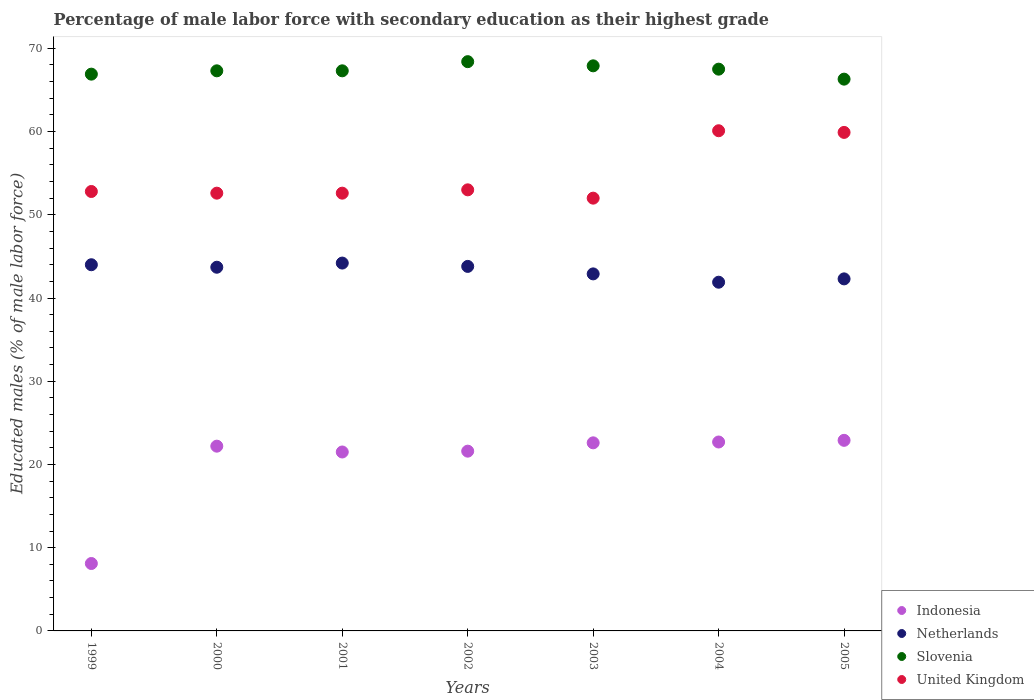How many different coloured dotlines are there?
Your answer should be very brief. 4. What is the percentage of male labor force with secondary education in Indonesia in 2004?
Ensure brevity in your answer.  22.7. Across all years, what is the maximum percentage of male labor force with secondary education in Netherlands?
Your response must be concise. 44.2. Across all years, what is the minimum percentage of male labor force with secondary education in Netherlands?
Your answer should be compact. 41.9. In which year was the percentage of male labor force with secondary education in Indonesia maximum?
Your answer should be compact. 2005. In which year was the percentage of male labor force with secondary education in United Kingdom minimum?
Provide a succinct answer. 2003. What is the total percentage of male labor force with secondary education in Indonesia in the graph?
Keep it short and to the point. 141.6. What is the difference between the percentage of male labor force with secondary education in Indonesia in 1999 and that in 2001?
Keep it short and to the point. -13.4. What is the difference between the percentage of male labor force with secondary education in Slovenia in 2003 and the percentage of male labor force with secondary education in United Kingdom in 1999?
Your response must be concise. 15.1. What is the average percentage of male labor force with secondary education in Netherlands per year?
Ensure brevity in your answer.  43.26. In the year 2000, what is the difference between the percentage of male labor force with secondary education in Indonesia and percentage of male labor force with secondary education in Slovenia?
Provide a succinct answer. -45.1. What is the ratio of the percentage of male labor force with secondary education in Slovenia in 2000 to that in 2003?
Keep it short and to the point. 0.99. What is the difference between the highest and the lowest percentage of male labor force with secondary education in United Kingdom?
Make the answer very short. 8.1. Is it the case that in every year, the sum of the percentage of male labor force with secondary education in Slovenia and percentage of male labor force with secondary education in Netherlands  is greater than the sum of percentage of male labor force with secondary education in United Kingdom and percentage of male labor force with secondary education in Indonesia?
Offer a terse response. No. Does the percentage of male labor force with secondary education in United Kingdom monotonically increase over the years?
Offer a terse response. No. Is the percentage of male labor force with secondary education in Netherlands strictly greater than the percentage of male labor force with secondary education in Slovenia over the years?
Ensure brevity in your answer.  No. How many dotlines are there?
Ensure brevity in your answer.  4. How many years are there in the graph?
Offer a terse response. 7. What is the difference between two consecutive major ticks on the Y-axis?
Your response must be concise. 10. Are the values on the major ticks of Y-axis written in scientific E-notation?
Offer a terse response. No. Does the graph contain any zero values?
Offer a terse response. No. Does the graph contain grids?
Provide a short and direct response. No. Where does the legend appear in the graph?
Your answer should be compact. Bottom right. How many legend labels are there?
Offer a terse response. 4. How are the legend labels stacked?
Offer a terse response. Vertical. What is the title of the graph?
Make the answer very short. Percentage of male labor force with secondary education as their highest grade. Does "Sierra Leone" appear as one of the legend labels in the graph?
Keep it short and to the point. No. What is the label or title of the Y-axis?
Provide a succinct answer. Educated males (% of male labor force). What is the Educated males (% of male labor force) of Indonesia in 1999?
Your response must be concise. 8.1. What is the Educated males (% of male labor force) of Slovenia in 1999?
Ensure brevity in your answer.  66.9. What is the Educated males (% of male labor force) in United Kingdom in 1999?
Make the answer very short. 52.8. What is the Educated males (% of male labor force) in Indonesia in 2000?
Ensure brevity in your answer.  22.2. What is the Educated males (% of male labor force) of Netherlands in 2000?
Your response must be concise. 43.7. What is the Educated males (% of male labor force) of Slovenia in 2000?
Provide a short and direct response. 67.3. What is the Educated males (% of male labor force) of United Kingdom in 2000?
Give a very brief answer. 52.6. What is the Educated males (% of male labor force) in Indonesia in 2001?
Your answer should be compact. 21.5. What is the Educated males (% of male labor force) in Netherlands in 2001?
Your answer should be very brief. 44.2. What is the Educated males (% of male labor force) of Slovenia in 2001?
Provide a succinct answer. 67.3. What is the Educated males (% of male labor force) of United Kingdom in 2001?
Offer a very short reply. 52.6. What is the Educated males (% of male labor force) of Indonesia in 2002?
Provide a succinct answer. 21.6. What is the Educated males (% of male labor force) of Netherlands in 2002?
Keep it short and to the point. 43.8. What is the Educated males (% of male labor force) of Slovenia in 2002?
Your answer should be very brief. 68.4. What is the Educated males (% of male labor force) of Indonesia in 2003?
Provide a short and direct response. 22.6. What is the Educated males (% of male labor force) of Netherlands in 2003?
Offer a terse response. 42.9. What is the Educated males (% of male labor force) of Slovenia in 2003?
Ensure brevity in your answer.  67.9. What is the Educated males (% of male labor force) in United Kingdom in 2003?
Ensure brevity in your answer.  52. What is the Educated males (% of male labor force) of Indonesia in 2004?
Keep it short and to the point. 22.7. What is the Educated males (% of male labor force) in Netherlands in 2004?
Provide a succinct answer. 41.9. What is the Educated males (% of male labor force) in Slovenia in 2004?
Make the answer very short. 67.5. What is the Educated males (% of male labor force) of United Kingdom in 2004?
Provide a short and direct response. 60.1. What is the Educated males (% of male labor force) of Indonesia in 2005?
Keep it short and to the point. 22.9. What is the Educated males (% of male labor force) in Netherlands in 2005?
Offer a terse response. 42.3. What is the Educated males (% of male labor force) of Slovenia in 2005?
Make the answer very short. 66.3. What is the Educated males (% of male labor force) in United Kingdom in 2005?
Provide a short and direct response. 59.9. Across all years, what is the maximum Educated males (% of male labor force) of Indonesia?
Provide a succinct answer. 22.9. Across all years, what is the maximum Educated males (% of male labor force) of Netherlands?
Your response must be concise. 44.2. Across all years, what is the maximum Educated males (% of male labor force) of Slovenia?
Make the answer very short. 68.4. Across all years, what is the maximum Educated males (% of male labor force) in United Kingdom?
Give a very brief answer. 60.1. Across all years, what is the minimum Educated males (% of male labor force) in Indonesia?
Provide a short and direct response. 8.1. Across all years, what is the minimum Educated males (% of male labor force) in Netherlands?
Provide a short and direct response. 41.9. Across all years, what is the minimum Educated males (% of male labor force) of Slovenia?
Offer a terse response. 66.3. What is the total Educated males (% of male labor force) in Indonesia in the graph?
Make the answer very short. 141.6. What is the total Educated males (% of male labor force) of Netherlands in the graph?
Keep it short and to the point. 302.8. What is the total Educated males (% of male labor force) of Slovenia in the graph?
Offer a terse response. 471.6. What is the total Educated males (% of male labor force) in United Kingdom in the graph?
Offer a terse response. 383. What is the difference between the Educated males (% of male labor force) in Indonesia in 1999 and that in 2000?
Keep it short and to the point. -14.1. What is the difference between the Educated males (% of male labor force) of Netherlands in 1999 and that in 2000?
Make the answer very short. 0.3. What is the difference between the Educated males (% of male labor force) in Slovenia in 1999 and that in 2000?
Provide a succinct answer. -0.4. What is the difference between the Educated males (% of male labor force) of United Kingdom in 1999 and that in 2001?
Your answer should be very brief. 0.2. What is the difference between the Educated males (% of male labor force) in Slovenia in 1999 and that in 2002?
Offer a terse response. -1.5. What is the difference between the Educated males (% of male labor force) of Slovenia in 1999 and that in 2003?
Provide a succinct answer. -1. What is the difference between the Educated males (% of male labor force) of United Kingdom in 1999 and that in 2003?
Your response must be concise. 0.8. What is the difference between the Educated males (% of male labor force) in Indonesia in 1999 and that in 2004?
Offer a very short reply. -14.6. What is the difference between the Educated males (% of male labor force) of United Kingdom in 1999 and that in 2004?
Keep it short and to the point. -7.3. What is the difference between the Educated males (% of male labor force) of Indonesia in 1999 and that in 2005?
Provide a succinct answer. -14.8. What is the difference between the Educated males (% of male labor force) in Slovenia in 2000 and that in 2001?
Your response must be concise. 0. What is the difference between the Educated males (% of male labor force) of Netherlands in 2000 and that in 2002?
Make the answer very short. -0.1. What is the difference between the Educated males (% of male labor force) in Slovenia in 2000 and that in 2003?
Your answer should be very brief. -0.6. What is the difference between the Educated males (% of male labor force) in United Kingdom in 2000 and that in 2003?
Make the answer very short. 0.6. What is the difference between the Educated males (% of male labor force) of Indonesia in 2000 and that in 2004?
Your response must be concise. -0.5. What is the difference between the Educated males (% of male labor force) in Slovenia in 2000 and that in 2004?
Offer a very short reply. -0.2. What is the difference between the Educated males (% of male labor force) of United Kingdom in 2000 and that in 2004?
Make the answer very short. -7.5. What is the difference between the Educated males (% of male labor force) of Indonesia in 2000 and that in 2005?
Your answer should be compact. -0.7. What is the difference between the Educated males (% of male labor force) of Indonesia in 2001 and that in 2002?
Offer a terse response. -0.1. What is the difference between the Educated males (% of male labor force) of Netherlands in 2001 and that in 2002?
Provide a succinct answer. 0.4. What is the difference between the Educated males (% of male labor force) of Slovenia in 2001 and that in 2002?
Your response must be concise. -1.1. What is the difference between the Educated males (% of male labor force) of Indonesia in 2001 and that in 2003?
Make the answer very short. -1.1. What is the difference between the Educated males (% of male labor force) in Netherlands in 2001 and that in 2003?
Keep it short and to the point. 1.3. What is the difference between the Educated males (% of male labor force) of Indonesia in 2001 and that in 2004?
Make the answer very short. -1.2. What is the difference between the Educated males (% of male labor force) of Netherlands in 2001 and that in 2004?
Keep it short and to the point. 2.3. What is the difference between the Educated males (% of male labor force) in Indonesia in 2001 and that in 2005?
Ensure brevity in your answer.  -1.4. What is the difference between the Educated males (% of male labor force) in Netherlands in 2001 and that in 2005?
Provide a succinct answer. 1.9. What is the difference between the Educated males (% of male labor force) in Slovenia in 2001 and that in 2005?
Keep it short and to the point. 1. What is the difference between the Educated males (% of male labor force) in United Kingdom in 2002 and that in 2003?
Your answer should be compact. 1. What is the difference between the Educated males (% of male labor force) of Netherlands in 2002 and that in 2004?
Offer a very short reply. 1.9. What is the difference between the Educated males (% of male labor force) of Slovenia in 2002 and that in 2004?
Offer a very short reply. 0.9. What is the difference between the Educated males (% of male labor force) of Indonesia in 2002 and that in 2005?
Provide a short and direct response. -1.3. What is the difference between the Educated males (% of male labor force) in United Kingdom in 2002 and that in 2005?
Your response must be concise. -6.9. What is the difference between the Educated males (% of male labor force) in Indonesia in 2003 and that in 2004?
Offer a very short reply. -0.1. What is the difference between the Educated males (% of male labor force) of Slovenia in 2003 and that in 2004?
Offer a very short reply. 0.4. What is the difference between the Educated males (% of male labor force) in Indonesia in 2003 and that in 2005?
Keep it short and to the point. -0.3. What is the difference between the Educated males (% of male labor force) in Slovenia in 2003 and that in 2005?
Ensure brevity in your answer.  1.6. What is the difference between the Educated males (% of male labor force) in United Kingdom in 2003 and that in 2005?
Ensure brevity in your answer.  -7.9. What is the difference between the Educated males (% of male labor force) in Indonesia in 2004 and that in 2005?
Provide a succinct answer. -0.2. What is the difference between the Educated males (% of male labor force) in Netherlands in 2004 and that in 2005?
Offer a very short reply. -0.4. What is the difference between the Educated males (% of male labor force) of Slovenia in 2004 and that in 2005?
Your answer should be very brief. 1.2. What is the difference between the Educated males (% of male labor force) of Indonesia in 1999 and the Educated males (% of male labor force) of Netherlands in 2000?
Offer a terse response. -35.6. What is the difference between the Educated males (% of male labor force) in Indonesia in 1999 and the Educated males (% of male labor force) in Slovenia in 2000?
Provide a succinct answer. -59.2. What is the difference between the Educated males (% of male labor force) of Indonesia in 1999 and the Educated males (% of male labor force) of United Kingdom in 2000?
Provide a short and direct response. -44.5. What is the difference between the Educated males (% of male labor force) in Netherlands in 1999 and the Educated males (% of male labor force) in Slovenia in 2000?
Keep it short and to the point. -23.3. What is the difference between the Educated males (% of male labor force) in Netherlands in 1999 and the Educated males (% of male labor force) in United Kingdom in 2000?
Your response must be concise. -8.6. What is the difference between the Educated males (% of male labor force) of Indonesia in 1999 and the Educated males (% of male labor force) of Netherlands in 2001?
Make the answer very short. -36.1. What is the difference between the Educated males (% of male labor force) in Indonesia in 1999 and the Educated males (% of male labor force) in Slovenia in 2001?
Provide a succinct answer. -59.2. What is the difference between the Educated males (% of male labor force) of Indonesia in 1999 and the Educated males (% of male labor force) of United Kingdom in 2001?
Provide a succinct answer. -44.5. What is the difference between the Educated males (% of male labor force) in Netherlands in 1999 and the Educated males (% of male labor force) in Slovenia in 2001?
Your answer should be compact. -23.3. What is the difference between the Educated males (% of male labor force) of Slovenia in 1999 and the Educated males (% of male labor force) of United Kingdom in 2001?
Your answer should be very brief. 14.3. What is the difference between the Educated males (% of male labor force) of Indonesia in 1999 and the Educated males (% of male labor force) of Netherlands in 2002?
Your answer should be compact. -35.7. What is the difference between the Educated males (% of male labor force) in Indonesia in 1999 and the Educated males (% of male labor force) in Slovenia in 2002?
Your answer should be very brief. -60.3. What is the difference between the Educated males (% of male labor force) of Indonesia in 1999 and the Educated males (% of male labor force) of United Kingdom in 2002?
Offer a terse response. -44.9. What is the difference between the Educated males (% of male labor force) in Netherlands in 1999 and the Educated males (% of male labor force) in Slovenia in 2002?
Provide a short and direct response. -24.4. What is the difference between the Educated males (% of male labor force) in Slovenia in 1999 and the Educated males (% of male labor force) in United Kingdom in 2002?
Provide a succinct answer. 13.9. What is the difference between the Educated males (% of male labor force) in Indonesia in 1999 and the Educated males (% of male labor force) in Netherlands in 2003?
Keep it short and to the point. -34.8. What is the difference between the Educated males (% of male labor force) of Indonesia in 1999 and the Educated males (% of male labor force) of Slovenia in 2003?
Your answer should be compact. -59.8. What is the difference between the Educated males (% of male labor force) of Indonesia in 1999 and the Educated males (% of male labor force) of United Kingdom in 2003?
Your response must be concise. -43.9. What is the difference between the Educated males (% of male labor force) in Netherlands in 1999 and the Educated males (% of male labor force) in Slovenia in 2003?
Keep it short and to the point. -23.9. What is the difference between the Educated males (% of male labor force) of Slovenia in 1999 and the Educated males (% of male labor force) of United Kingdom in 2003?
Provide a succinct answer. 14.9. What is the difference between the Educated males (% of male labor force) of Indonesia in 1999 and the Educated males (% of male labor force) of Netherlands in 2004?
Keep it short and to the point. -33.8. What is the difference between the Educated males (% of male labor force) of Indonesia in 1999 and the Educated males (% of male labor force) of Slovenia in 2004?
Offer a terse response. -59.4. What is the difference between the Educated males (% of male labor force) in Indonesia in 1999 and the Educated males (% of male labor force) in United Kingdom in 2004?
Give a very brief answer. -52. What is the difference between the Educated males (% of male labor force) of Netherlands in 1999 and the Educated males (% of male labor force) of Slovenia in 2004?
Offer a terse response. -23.5. What is the difference between the Educated males (% of male labor force) of Netherlands in 1999 and the Educated males (% of male labor force) of United Kingdom in 2004?
Give a very brief answer. -16.1. What is the difference between the Educated males (% of male labor force) of Indonesia in 1999 and the Educated males (% of male labor force) of Netherlands in 2005?
Make the answer very short. -34.2. What is the difference between the Educated males (% of male labor force) in Indonesia in 1999 and the Educated males (% of male labor force) in Slovenia in 2005?
Give a very brief answer. -58.2. What is the difference between the Educated males (% of male labor force) in Indonesia in 1999 and the Educated males (% of male labor force) in United Kingdom in 2005?
Offer a terse response. -51.8. What is the difference between the Educated males (% of male labor force) of Netherlands in 1999 and the Educated males (% of male labor force) of Slovenia in 2005?
Make the answer very short. -22.3. What is the difference between the Educated males (% of male labor force) of Netherlands in 1999 and the Educated males (% of male labor force) of United Kingdom in 2005?
Offer a very short reply. -15.9. What is the difference between the Educated males (% of male labor force) of Indonesia in 2000 and the Educated males (% of male labor force) of Netherlands in 2001?
Ensure brevity in your answer.  -22. What is the difference between the Educated males (% of male labor force) in Indonesia in 2000 and the Educated males (% of male labor force) in Slovenia in 2001?
Offer a terse response. -45.1. What is the difference between the Educated males (% of male labor force) of Indonesia in 2000 and the Educated males (% of male labor force) of United Kingdom in 2001?
Ensure brevity in your answer.  -30.4. What is the difference between the Educated males (% of male labor force) in Netherlands in 2000 and the Educated males (% of male labor force) in Slovenia in 2001?
Offer a very short reply. -23.6. What is the difference between the Educated males (% of male labor force) of Slovenia in 2000 and the Educated males (% of male labor force) of United Kingdom in 2001?
Make the answer very short. 14.7. What is the difference between the Educated males (% of male labor force) in Indonesia in 2000 and the Educated males (% of male labor force) in Netherlands in 2002?
Your response must be concise. -21.6. What is the difference between the Educated males (% of male labor force) in Indonesia in 2000 and the Educated males (% of male labor force) in Slovenia in 2002?
Ensure brevity in your answer.  -46.2. What is the difference between the Educated males (% of male labor force) in Indonesia in 2000 and the Educated males (% of male labor force) in United Kingdom in 2002?
Offer a very short reply. -30.8. What is the difference between the Educated males (% of male labor force) in Netherlands in 2000 and the Educated males (% of male labor force) in Slovenia in 2002?
Your answer should be compact. -24.7. What is the difference between the Educated males (% of male labor force) in Netherlands in 2000 and the Educated males (% of male labor force) in United Kingdom in 2002?
Your answer should be compact. -9.3. What is the difference between the Educated males (% of male labor force) of Slovenia in 2000 and the Educated males (% of male labor force) of United Kingdom in 2002?
Offer a terse response. 14.3. What is the difference between the Educated males (% of male labor force) of Indonesia in 2000 and the Educated males (% of male labor force) of Netherlands in 2003?
Ensure brevity in your answer.  -20.7. What is the difference between the Educated males (% of male labor force) of Indonesia in 2000 and the Educated males (% of male labor force) of Slovenia in 2003?
Ensure brevity in your answer.  -45.7. What is the difference between the Educated males (% of male labor force) in Indonesia in 2000 and the Educated males (% of male labor force) in United Kingdom in 2003?
Provide a succinct answer. -29.8. What is the difference between the Educated males (% of male labor force) of Netherlands in 2000 and the Educated males (% of male labor force) of Slovenia in 2003?
Keep it short and to the point. -24.2. What is the difference between the Educated males (% of male labor force) in Slovenia in 2000 and the Educated males (% of male labor force) in United Kingdom in 2003?
Your response must be concise. 15.3. What is the difference between the Educated males (% of male labor force) in Indonesia in 2000 and the Educated males (% of male labor force) in Netherlands in 2004?
Keep it short and to the point. -19.7. What is the difference between the Educated males (% of male labor force) of Indonesia in 2000 and the Educated males (% of male labor force) of Slovenia in 2004?
Give a very brief answer. -45.3. What is the difference between the Educated males (% of male labor force) in Indonesia in 2000 and the Educated males (% of male labor force) in United Kingdom in 2004?
Keep it short and to the point. -37.9. What is the difference between the Educated males (% of male labor force) in Netherlands in 2000 and the Educated males (% of male labor force) in Slovenia in 2004?
Offer a terse response. -23.8. What is the difference between the Educated males (% of male labor force) in Netherlands in 2000 and the Educated males (% of male labor force) in United Kingdom in 2004?
Make the answer very short. -16.4. What is the difference between the Educated males (% of male labor force) of Slovenia in 2000 and the Educated males (% of male labor force) of United Kingdom in 2004?
Provide a short and direct response. 7.2. What is the difference between the Educated males (% of male labor force) in Indonesia in 2000 and the Educated males (% of male labor force) in Netherlands in 2005?
Your answer should be very brief. -20.1. What is the difference between the Educated males (% of male labor force) of Indonesia in 2000 and the Educated males (% of male labor force) of Slovenia in 2005?
Provide a succinct answer. -44.1. What is the difference between the Educated males (% of male labor force) in Indonesia in 2000 and the Educated males (% of male labor force) in United Kingdom in 2005?
Give a very brief answer. -37.7. What is the difference between the Educated males (% of male labor force) of Netherlands in 2000 and the Educated males (% of male labor force) of Slovenia in 2005?
Your answer should be compact. -22.6. What is the difference between the Educated males (% of male labor force) in Netherlands in 2000 and the Educated males (% of male labor force) in United Kingdom in 2005?
Keep it short and to the point. -16.2. What is the difference between the Educated males (% of male labor force) of Slovenia in 2000 and the Educated males (% of male labor force) of United Kingdom in 2005?
Your answer should be compact. 7.4. What is the difference between the Educated males (% of male labor force) in Indonesia in 2001 and the Educated males (% of male labor force) in Netherlands in 2002?
Provide a short and direct response. -22.3. What is the difference between the Educated males (% of male labor force) in Indonesia in 2001 and the Educated males (% of male labor force) in Slovenia in 2002?
Your answer should be very brief. -46.9. What is the difference between the Educated males (% of male labor force) of Indonesia in 2001 and the Educated males (% of male labor force) of United Kingdom in 2002?
Keep it short and to the point. -31.5. What is the difference between the Educated males (% of male labor force) of Netherlands in 2001 and the Educated males (% of male labor force) of Slovenia in 2002?
Your response must be concise. -24.2. What is the difference between the Educated males (% of male labor force) in Indonesia in 2001 and the Educated males (% of male labor force) in Netherlands in 2003?
Your answer should be compact. -21.4. What is the difference between the Educated males (% of male labor force) in Indonesia in 2001 and the Educated males (% of male labor force) in Slovenia in 2003?
Your answer should be compact. -46.4. What is the difference between the Educated males (% of male labor force) of Indonesia in 2001 and the Educated males (% of male labor force) of United Kingdom in 2003?
Offer a terse response. -30.5. What is the difference between the Educated males (% of male labor force) of Netherlands in 2001 and the Educated males (% of male labor force) of Slovenia in 2003?
Offer a very short reply. -23.7. What is the difference between the Educated males (% of male labor force) in Slovenia in 2001 and the Educated males (% of male labor force) in United Kingdom in 2003?
Your response must be concise. 15.3. What is the difference between the Educated males (% of male labor force) of Indonesia in 2001 and the Educated males (% of male labor force) of Netherlands in 2004?
Ensure brevity in your answer.  -20.4. What is the difference between the Educated males (% of male labor force) of Indonesia in 2001 and the Educated males (% of male labor force) of Slovenia in 2004?
Make the answer very short. -46. What is the difference between the Educated males (% of male labor force) in Indonesia in 2001 and the Educated males (% of male labor force) in United Kingdom in 2004?
Your answer should be very brief. -38.6. What is the difference between the Educated males (% of male labor force) of Netherlands in 2001 and the Educated males (% of male labor force) of Slovenia in 2004?
Your answer should be very brief. -23.3. What is the difference between the Educated males (% of male labor force) in Netherlands in 2001 and the Educated males (% of male labor force) in United Kingdom in 2004?
Ensure brevity in your answer.  -15.9. What is the difference between the Educated males (% of male labor force) in Indonesia in 2001 and the Educated males (% of male labor force) in Netherlands in 2005?
Your answer should be very brief. -20.8. What is the difference between the Educated males (% of male labor force) of Indonesia in 2001 and the Educated males (% of male labor force) of Slovenia in 2005?
Provide a succinct answer. -44.8. What is the difference between the Educated males (% of male labor force) in Indonesia in 2001 and the Educated males (% of male labor force) in United Kingdom in 2005?
Provide a short and direct response. -38.4. What is the difference between the Educated males (% of male labor force) of Netherlands in 2001 and the Educated males (% of male labor force) of Slovenia in 2005?
Keep it short and to the point. -22.1. What is the difference between the Educated males (% of male labor force) in Netherlands in 2001 and the Educated males (% of male labor force) in United Kingdom in 2005?
Your answer should be compact. -15.7. What is the difference between the Educated males (% of male labor force) in Slovenia in 2001 and the Educated males (% of male labor force) in United Kingdom in 2005?
Make the answer very short. 7.4. What is the difference between the Educated males (% of male labor force) of Indonesia in 2002 and the Educated males (% of male labor force) of Netherlands in 2003?
Your answer should be compact. -21.3. What is the difference between the Educated males (% of male labor force) in Indonesia in 2002 and the Educated males (% of male labor force) in Slovenia in 2003?
Provide a succinct answer. -46.3. What is the difference between the Educated males (% of male labor force) in Indonesia in 2002 and the Educated males (% of male labor force) in United Kingdom in 2003?
Your answer should be compact. -30.4. What is the difference between the Educated males (% of male labor force) in Netherlands in 2002 and the Educated males (% of male labor force) in Slovenia in 2003?
Ensure brevity in your answer.  -24.1. What is the difference between the Educated males (% of male labor force) in Netherlands in 2002 and the Educated males (% of male labor force) in United Kingdom in 2003?
Give a very brief answer. -8.2. What is the difference between the Educated males (% of male labor force) in Indonesia in 2002 and the Educated males (% of male labor force) in Netherlands in 2004?
Ensure brevity in your answer.  -20.3. What is the difference between the Educated males (% of male labor force) in Indonesia in 2002 and the Educated males (% of male labor force) in Slovenia in 2004?
Your answer should be compact. -45.9. What is the difference between the Educated males (% of male labor force) in Indonesia in 2002 and the Educated males (% of male labor force) in United Kingdom in 2004?
Keep it short and to the point. -38.5. What is the difference between the Educated males (% of male labor force) in Netherlands in 2002 and the Educated males (% of male labor force) in Slovenia in 2004?
Provide a short and direct response. -23.7. What is the difference between the Educated males (% of male labor force) in Netherlands in 2002 and the Educated males (% of male labor force) in United Kingdom in 2004?
Give a very brief answer. -16.3. What is the difference between the Educated males (% of male labor force) in Indonesia in 2002 and the Educated males (% of male labor force) in Netherlands in 2005?
Keep it short and to the point. -20.7. What is the difference between the Educated males (% of male labor force) in Indonesia in 2002 and the Educated males (% of male labor force) in Slovenia in 2005?
Provide a short and direct response. -44.7. What is the difference between the Educated males (% of male labor force) in Indonesia in 2002 and the Educated males (% of male labor force) in United Kingdom in 2005?
Keep it short and to the point. -38.3. What is the difference between the Educated males (% of male labor force) of Netherlands in 2002 and the Educated males (% of male labor force) of Slovenia in 2005?
Keep it short and to the point. -22.5. What is the difference between the Educated males (% of male labor force) of Netherlands in 2002 and the Educated males (% of male labor force) of United Kingdom in 2005?
Provide a succinct answer. -16.1. What is the difference between the Educated males (% of male labor force) of Indonesia in 2003 and the Educated males (% of male labor force) of Netherlands in 2004?
Your answer should be very brief. -19.3. What is the difference between the Educated males (% of male labor force) of Indonesia in 2003 and the Educated males (% of male labor force) of Slovenia in 2004?
Your answer should be very brief. -44.9. What is the difference between the Educated males (% of male labor force) of Indonesia in 2003 and the Educated males (% of male labor force) of United Kingdom in 2004?
Your answer should be very brief. -37.5. What is the difference between the Educated males (% of male labor force) of Netherlands in 2003 and the Educated males (% of male labor force) of Slovenia in 2004?
Keep it short and to the point. -24.6. What is the difference between the Educated males (% of male labor force) in Netherlands in 2003 and the Educated males (% of male labor force) in United Kingdom in 2004?
Give a very brief answer. -17.2. What is the difference between the Educated males (% of male labor force) in Slovenia in 2003 and the Educated males (% of male labor force) in United Kingdom in 2004?
Keep it short and to the point. 7.8. What is the difference between the Educated males (% of male labor force) in Indonesia in 2003 and the Educated males (% of male labor force) in Netherlands in 2005?
Keep it short and to the point. -19.7. What is the difference between the Educated males (% of male labor force) of Indonesia in 2003 and the Educated males (% of male labor force) of Slovenia in 2005?
Your answer should be compact. -43.7. What is the difference between the Educated males (% of male labor force) in Indonesia in 2003 and the Educated males (% of male labor force) in United Kingdom in 2005?
Offer a terse response. -37.3. What is the difference between the Educated males (% of male labor force) of Netherlands in 2003 and the Educated males (% of male labor force) of Slovenia in 2005?
Keep it short and to the point. -23.4. What is the difference between the Educated males (% of male labor force) of Slovenia in 2003 and the Educated males (% of male labor force) of United Kingdom in 2005?
Ensure brevity in your answer.  8. What is the difference between the Educated males (% of male labor force) of Indonesia in 2004 and the Educated males (% of male labor force) of Netherlands in 2005?
Keep it short and to the point. -19.6. What is the difference between the Educated males (% of male labor force) of Indonesia in 2004 and the Educated males (% of male labor force) of Slovenia in 2005?
Make the answer very short. -43.6. What is the difference between the Educated males (% of male labor force) in Indonesia in 2004 and the Educated males (% of male labor force) in United Kingdom in 2005?
Keep it short and to the point. -37.2. What is the difference between the Educated males (% of male labor force) in Netherlands in 2004 and the Educated males (% of male labor force) in Slovenia in 2005?
Provide a short and direct response. -24.4. What is the difference between the Educated males (% of male labor force) of Netherlands in 2004 and the Educated males (% of male labor force) of United Kingdom in 2005?
Give a very brief answer. -18. What is the difference between the Educated males (% of male labor force) of Slovenia in 2004 and the Educated males (% of male labor force) of United Kingdom in 2005?
Your answer should be very brief. 7.6. What is the average Educated males (% of male labor force) in Indonesia per year?
Offer a terse response. 20.23. What is the average Educated males (% of male labor force) of Netherlands per year?
Give a very brief answer. 43.26. What is the average Educated males (% of male labor force) in Slovenia per year?
Provide a succinct answer. 67.37. What is the average Educated males (% of male labor force) of United Kingdom per year?
Make the answer very short. 54.71. In the year 1999, what is the difference between the Educated males (% of male labor force) in Indonesia and Educated males (% of male labor force) in Netherlands?
Your answer should be very brief. -35.9. In the year 1999, what is the difference between the Educated males (% of male labor force) of Indonesia and Educated males (% of male labor force) of Slovenia?
Make the answer very short. -58.8. In the year 1999, what is the difference between the Educated males (% of male labor force) in Indonesia and Educated males (% of male labor force) in United Kingdom?
Your answer should be very brief. -44.7. In the year 1999, what is the difference between the Educated males (% of male labor force) in Netherlands and Educated males (% of male labor force) in Slovenia?
Ensure brevity in your answer.  -22.9. In the year 2000, what is the difference between the Educated males (% of male labor force) of Indonesia and Educated males (% of male labor force) of Netherlands?
Your response must be concise. -21.5. In the year 2000, what is the difference between the Educated males (% of male labor force) in Indonesia and Educated males (% of male labor force) in Slovenia?
Provide a short and direct response. -45.1. In the year 2000, what is the difference between the Educated males (% of male labor force) of Indonesia and Educated males (% of male labor force) of United Kingdom?
Your answer should be very brief. -30.4. In the year 2000, what is the difference between the Educated males (% of male labor force) in Netherlands and Educated males (% of male labor force) in Slovenia?
Keep it short and to the point. -23.6. In the year 2000, what is the difference between the Educated males (% of male labor force) in Slovenia and Educated males (% of male labor force) in United Kingdom?
Provide a succinct answer. 14.7. In the year 2001, what is the difference between the Educated males (% of male labor force) of Indonesia and Educated males (% of male labor force) of Netherlands?
Provide a succinct answer. -22.7. In the year 2001, what is the difference between the Educated males (% of male labor force) of Indonesia and Educated males (% of male labor force) of Slovenia?
Your answer should be very brief. -45.8. In the year 2001, what is the difference between the Educated males (% of male labor force) of Indonesia and Educated males (% of male labor force) of United Kingdom?
Ensure brevity in your answer.  -31.1. In the year 2001, what is the difference between the Educated males (% of male labor force) of Netherlands and Educated males (% of male labor force) of Slovenia?
Give a very brief answer. -23.1. In the year 2001, what is the difference between the Educated males (% of male labor force) of Netherlands and Educated males (% of male labor force) of United Kingdom?
Your response must be concise. -8.4. In the year 2002, what is the difference between the Educated males (% of male labor force) in Indonesia and Educated males (% of male labor force) in Netherlands?
Your answer should be compact. -22.2. In the year 2002, what is the difference between the Educated males (% of male labor force) in Indonesia and Educated males (% of male labor force) in Slovenia?
Offer a very short reply. -46.8. In the year 2002, what is the difference between the Educated males (% of male labor force) in Indonesia and Educated males (% of male labor force) in United Kingdom?
Offer a terse response. -31.4. In the year 2002, what is the difference between the Educated males (% of male labor force) of Netherlands and Educated males (% of male labor force) of Slovenia?
Provide a short and direct response. -24.6. In the year 2002, what is the difference between the Educated males (% of male labor force) of Netherlands and Educated males (% of male labor force) of United Kingdom?
Your response must be concise. -9.2. In the year 2002, what is the difference between the Educated males (% of male labor force) in Slovenia and Educated males (% of male labor force) in United Kingdom?
Offer a very short reply. 15.4. In the year 2003, what is the difference between the Educated males (% of male labor force) in Indonesia and Educated males (% of male labor force) in Netherlands?
Your response must be concise. -20.3. In the year 2003, what is the difference between the Educated males (% of male labor force) in Indonesia and Educated males (% of male labor force) in Slovenia?
Make the answer very short. -45.3. In the year 2003, what is the difference between the Educated males (% of male labor force) of Indonesia and Educated males (% of male labor force) of United Kingdom?
Offer a very short reply. -29.4. In the year 2003, what is the difference between the Educated males (% of male labor force) in Netherlands and Educated males (% of male labor force) in Slovenia?
Provide a short and direct response. -25. In the year 2003, what is the difference between the Educated males (% of male labor force) in Netherlands and Educated males (% of male labor force) in United Kingdom?
Your response must be concise. -9.1. In the year 2004, what is the difference between the Educated males (% of male labor force) in Indonesia and Educated males (% of male labor force) in Netherlands?
Your response must be concise. -19.2. In the year 2004, what is the difference between the Educated males (% of male labor force) in Indonesia and Educated males (% of male labor force) in Slovenia?
Offer a very short reply. -44.8. In the year 2004, what is the difference between the Educated males (% of male labor force) of Indonesia and Educated males (% of male labor force) of United Kingdom?
Keep it short and to the point. -37.4. In the year 2004, what is the difference between the Educated males (% of male labor force) of Netherlands and Educated males (% of male labor force) of Slovenia?
Offer a very short reply. -25.6. In the year 2004, what is the difference between the Educated males (% of male labor force) in Netherlands and Educated males (% of male labor force) in United Kingdom?
Your answer should be compact. -18.2. In the year 2005, what is the difference between the Educated males (% of male labor force) of Indonesia and Educated males (% of male labor force) of Netherlands?
Your answer should be compact. -19.4. In the year 2005, what is the difference between the Educated males (% of male labor force) of Indonesia and Educated males (% of male labor force) of Slovenia?
Provide a succinct answer. -43.4. In the year 2005, what is the difference between the Educated males (% of male labor force) of Indonesia and Educated males (% of male labor force) of United Kingdom?
Provide a succinct answer. -37. In the year 2005, what is the difference between the Educated males (% of male labor force) of Netherlands and Educated males (% of male labor force) of United Kingdom?
Ensure brevity in your answer.  -17.6. What is the ratio of the Educated males (% of male labor force) of Indonesia in 1999 to that in 2000?
Ensure brevity in your answer.  0.36. What is the ratio of the Educated males (% of male labor force) of Netherlands in 1999 to that in 2000?
Ensure brevity in your answer.  1.01. What is the ratio of the Educated males (% of male labor force) of Slovenia in 1999 to that in 2000?
Provide a succinct answer. 0.99. What is the ratio of the Educated males (% of male labor force) in Indonesia in 1999 to that in 2001?
Your answer should be compact. 0.38. What is the ratio of the Educated males (% of male labor force) in Netherlands in 1999 to that in 2001?
Provide a succinct answer. 1. What is the ratio of the Educated males (% of male labor force) of Slovenia in 1999 to that in 2001?
Offer a terse response. 0.99. What is the ratio of the Educated males (% of male labor force) in United Kingdom in 1999 to that in 2001?
Ensure brevity in your answer.  1. What is the ratio of the Educated males (% of male labor force) of Indonesia in 1999 to that in 2002?
Your answer should be very brief. 0.38. What is the ratio of the Educated males (% of male labor force) in Netherlands in 1999 to that in 2002?
Ensure brevity in your answer.  1. What is the ratio of the Educated males (% of male labor force) of Slovenia in 1999 to that in 2002?
Give a very brief answer. 0.98. What is the ratio of the Educated males (% of male labor force) in Indonesia in 1999 to that in 2003?
Give a very brief answer. 0.36. What is the ratio of the Educated males (% of male labor force) of Netherlands in 1999 to that in 2003?
Offer a terse response. 1.03. What is the ratio of the Educated males (% of male labor force) in United Kingdom in 1999 to that in 2003?
Provide a succinct answer. 1.02. What is the ratio of the Educated males (% of male labor force) in Indonesia in 1999 to that in 2004?
Offer a very short reply. 0.36. What is the ratio of the Educated males (% of male labor force) in Netherlands in 1999 to that in 2004?
Provide a short and direct response. 1.05. What is the ratio of the Educated males (% of male labor force) in Slovenia in 1999 to that in 2004?
Provide a short and direct response. 0.99. What is the ratio of the Educated males (% of male labor force) in United Kingdom in 1999 to that in 2004?
Keep it short and to the point. 0.88. What is the ratio of the Educated males (% of male labor force) in Indonesia in 1999 to that in 2005?
Make the answer very short. 0.35. What is the ratio of the Educated males (% of male labor force) of Netherlands in 1999 to that in 2005?
Ensure brevity in your answer.  1.04. What is the ratio of the Educated males (% of male labor force) of United Kingdom in 1999 to that in 2005?
Give a very brief answer. 0.88. What is the ratio of the Educated males (% of male labor force) in Indonesia in 2000 to that in 2001?
Your answer should be very brief. 1.03. What is the ratio of the Educated males (% of male labor force) in Netherlands in 2000 to that in 2001?
Your answer should be very brief. 0.99. What is the ratio of the Educated males (% of male labor force) of Slovenia in 2000 to that in 2001?
Your answer should be compact. 1. What is the ratio of the Educated males (% of male labor force) of Indonesia in 2000 to that in 2002?
Ensure brevity in your answer.  1.03. What is the ratio of the Educated males (% of male labor force) in Netherlands in 2000 to that in 2002?
Offer a terse response. 1. What is the ratio of the Educated males (% of male labor force) in Slovenia in 2000 to that in 2002?
Ensure brevity in your answer.  0.98. What is the ratio of the Educated males (% of male labor force) of Indonesia in 2000 to that in 2003?
Make the answer very short. 0.98. What is the ratio of the Educated males (% of male labor force) of Netherlands in 2000 to that in 2003?
Provide a short and direct response. 1.02. What is the ratio of the Educated males (% of male labor force) in Slovenia in 2000 to that in 2003?
Offer a very short reply. 0.99. What is the ratio of the Educated males (% of male labor force) of United Kingdom in 2000 to that in 2003?
Your answer should be compact. 1.01. What is the ratio of the Educated males (% of male labor force) of Indonesia in 2000 to that in 2004?
Provide a short and direct response. 0.98. What is the ratio of the Educated males (% of male labor force) of Netherlands in 2000 to that in 2004?
Provide a succinct answer. 1.04. What is the ratio of the Educated males (% of male labor force) in Slovenia in 2000 to that in 2004?
Offer a very short reply. 1. What is the ratio of the Educated males (% of male labor force) in United Kingdom in 2000 to that in 2004?
Ensure brevity in your answer.  0.88. What is the ratio of the Educated males (% of male labor force) in Indonesia in 2000 to that in 2005?
Your response must be concise. 0.97. What is the ratio of the Educated males (% of male labor force) of Netherlands in 2000 to that in 2005?
Provide a succinct answer. 1.03. What is the ratio of the Educated males (% of male labor force) in Slovenia in 2000 to that in 2005?
Provide a succinct answer. 1.02. What is the ratio of the Educated males (% of male labor force) in United Kingdom in 2000 to that in 2005?
Make the answer very short. 0.88. What is the ratio of the Educated males (% of male labor force) in Netherlands in 2001 to that in 2002?
Your answer should be very brief. 1.01. What is the ratio of the Educated males (% of male labor force) in Slovenia in 2001 to that in 2002?
Provide a short and direct response. 0.98. What is the ratio of the Educated males (% of male labor force) of Indonesia in 2001 to that in 2003?
Your answer should be very brief. 0.95. What is the ratio of the Educated males (% of male labor force) in Netherlands in 2001 to that in 2003?
Offer a very short reply. 1.03. What is the ratio of the Educated males (% of male labor force) of Slovenia in 2001 to that in 2003?
Your response must be concise. 0.99. What is the ratio of the Educated males (% of male labor force) of United Kingdom in 2001 to that in 2003?
Ensure brevity in your answer.  1.01. What is the ratio of the Educated males (% of male labor force) in Indonesia in 2001 to that in 2004?
Offer a terse response. 0.95. What is the ratio of the Educated males (% of male labor force) in Netherlands in 2001 to that in 2004?
Provide a succinct answer. 1.05. What is the ratio of the Educated males (% of male labor force) in Slovenia in 2001 to that in 2004?
Keep it short and to the point. 1. What is the ratio of the Educated males (% of male labor force) of United Kingdom in 2001 to that in 2004?
Provide a short and direct response. 0.88. What is the ratio of the Educated males (% of male labor force) of Indonesia in 2001 to that in 2005?
Provide a short and direct response. 0.94. What is the ratio of the Educated males (% of male labor force) in Netherlands in 2001 to that in 2005?
Keep it short and to the point. 1.04. What is the ratio of the Educated males (% of male labor force) of Slovenia in 2001 to that in 2005?
Give a very brief answer. 1.02. What is the ratio of the Educated males (% of male labor force) of United Kingdom in 2001 to that in 2005?
Offer a terse response. 0.88. What is the ratio of the Educated males (% of male labor force) in Indonesia in 2002 to that in 2003?
Keep it short and to the point. 0.96. What is the ratio of the Educated males (% of male labor force) in Slovenia in 2002 to that in 2003?
Make the answer very short. 1.01. What is the ratio of the Educated males (% of male labor force) of United Kingdom in 2002 to that in 2003?
Keep it short and to the point. 1.02. What is the ratio of the Educated males (% of male labor force) of Indonesia in 2002 to that in 2004?
Provide a succinct answer. 0.95. What is the ratio of the Educated males (% of male labor force) in Netherlands in 2002 to that in 2004?
Provide a succinct answer. 1.05. What is the ratio of the Educated males (% of male labor force) of Slovenia in 2002 to that in 2004?
Provide a succinct answer. 1.01. What is the ratio of the Educated males (% of male labor force) of United Kingdom in 2002 to that in 2004?
Offer a very short reply. 0.88. What is the ratio of the Educated males (% of male labor force) in Indonesia in 2002 to that in 2005?
Keep it short and to the point. 0.94. What is the ratio of the Educated males (% of male labor force) in Netherlands in 2002 to that in 2005?
Your answer should be compact. 1.04. What is the ratio of the Educated males (% of male labor force) in Slovenia in 2002 to that in 2005?
Provide a short and direct response. 1.03. What is the ratio of the Educated males (% of male labor force) in United Kingdom in 2002 to that in 2005?
Your answer should be compact. 0.88. What is the ratio of the Educated males (% of male labor force) in Netherlands in 2003 to that in 2004?
Provide a short and direct response. 1.02. What is the ratio of the Educated males (% of male labor force) in Slovenia in 2003 to that in 2004?
Provide a short and direct response. 1.01. What is the ratio of the Educated males (% of male labor force) in United Kingdom in 2003 to that in 2004?
Your answer should be compact. 0.87. What is the ratio of the Educated males (% of male labor force) of Indonesia in 2003 to that in 2005?
Give a very brief answer. 0.99. What is the ratio of the Educated males (% of male labor force) of Netherlands in 2003 to that in 2005?
Make the answer very short. 1.01. What is the ratio of the Educated males (% of male labor force) in Slovenia in 2003 to that in 2005?
Provide a short and direct response. 1.02. What is the ratio of the Educated males (% of male labor force) of United Kingdom in 2003 to that in 2005?
Ensure brevity in your answer.  0.87. What is the ratio of the Educated males (% of male labor force) of Slovenia in 2004 to that in 2005?
Make the answer very short. 1.02. What is the difference between the highest and the second highest Educated males (% of male labor force) in Netherlands?
Ensure brevity in your answer.  0.2. What is the difference between the highest and the second highest Educated males (% of male labor force) of Slovenia?
Your response must be concise. 0.5. What is the difference between the highest and the second highest Educated males (% of male labor force) of United Kingdom?
Your response must be concise. 0.2. What is the difference between the highest and the lowest Educated males (% of male labor force) in Indonesia?
Ensure brevity in your answer.  14.8. 